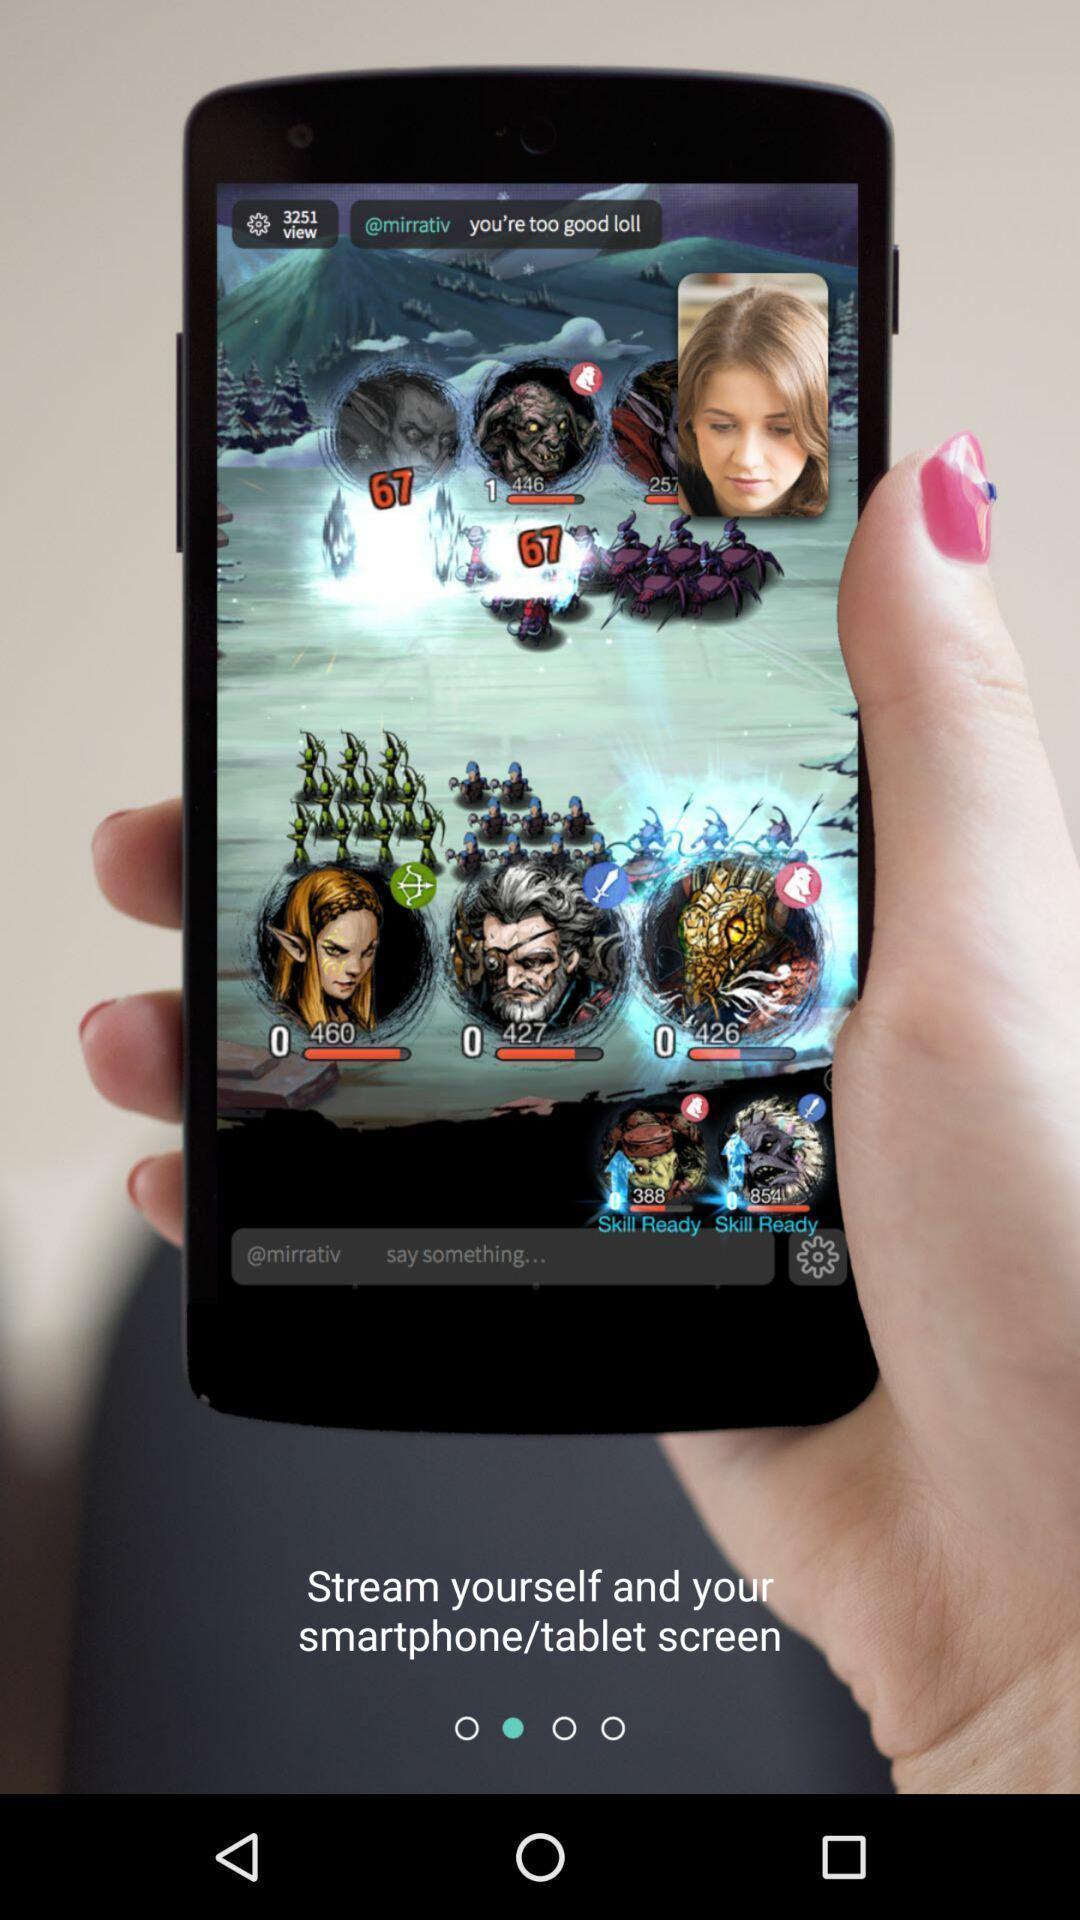What details can you identify in this image? Welcome page of streaming app. 